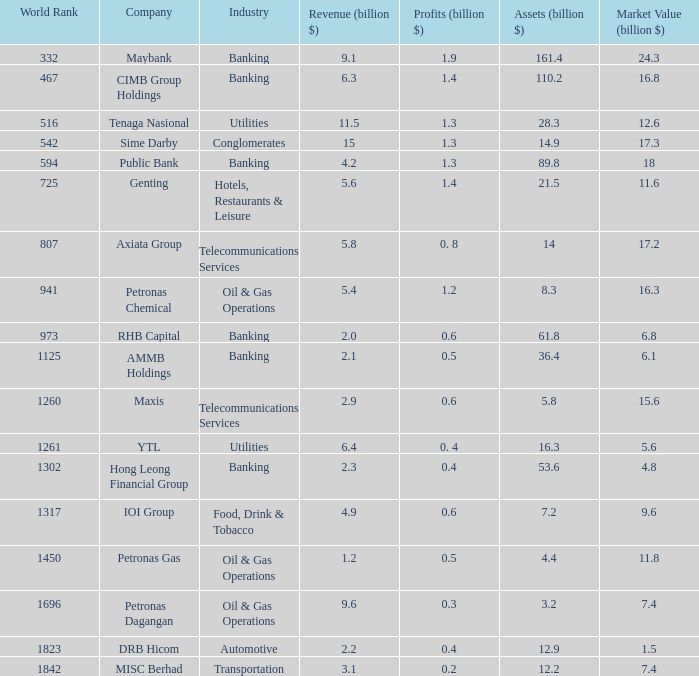8 0.5. 